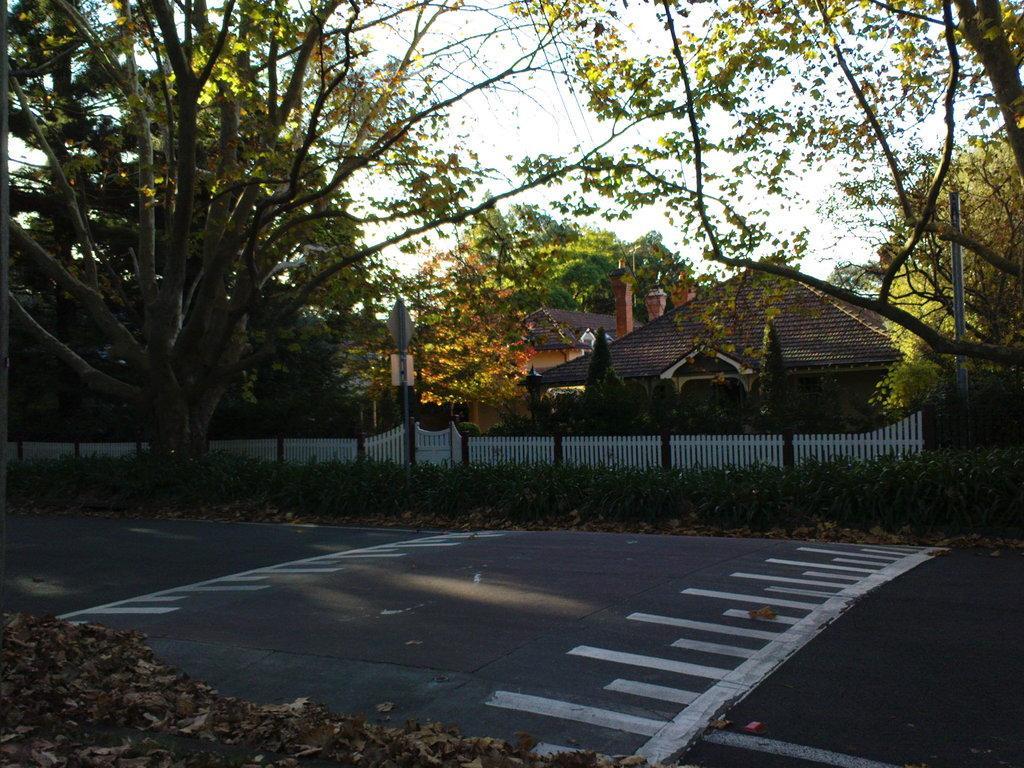Can you describe this image briefly? In this image I can see a road , on the road I can see a zebra crossing lines and I can see trees in front of the house and I can see a fence in front of the house and I can see a house in the middle and I can see the sky and power line cables at the top. 